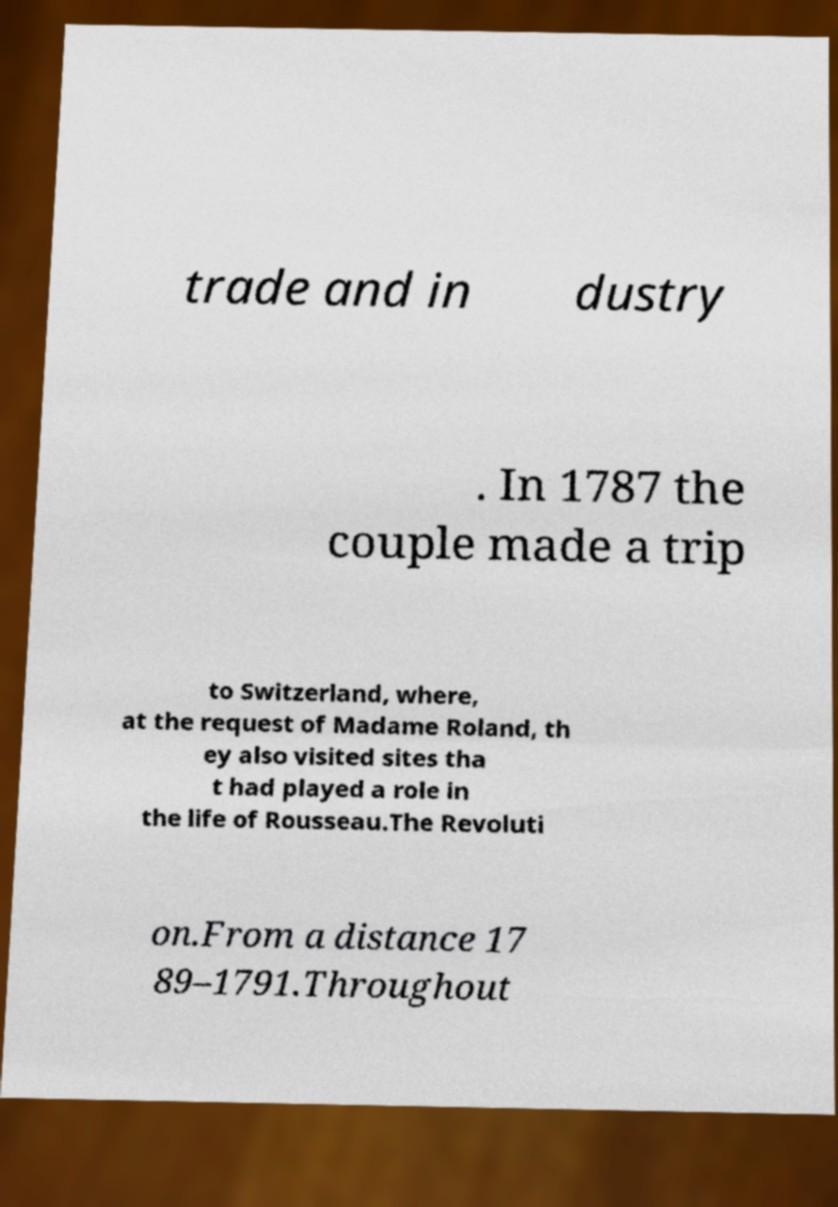Please identify and transcribe the text found in this image. trade and in dustry . In 1787 the couple made a trip to Switzerland, where, at the request of Madame Roland, th ey also visited sites tha t had played a role in the life of Rousseau.The Revoluti on.From a distance 17 89–1791.Throughout 